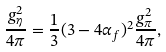<formula> <loc_0><loc_0><loc_500><loc_500>\frac { g _ { \eta } ^ { 2 } } { 4 \pi } = \frac { 1 } { 3 } ( 3 - 4 \alpha _ { f } ) ^ { 2 } \frac { g _ { \pi } ^ { 2 } } { 4 \pi } ,</formula> 